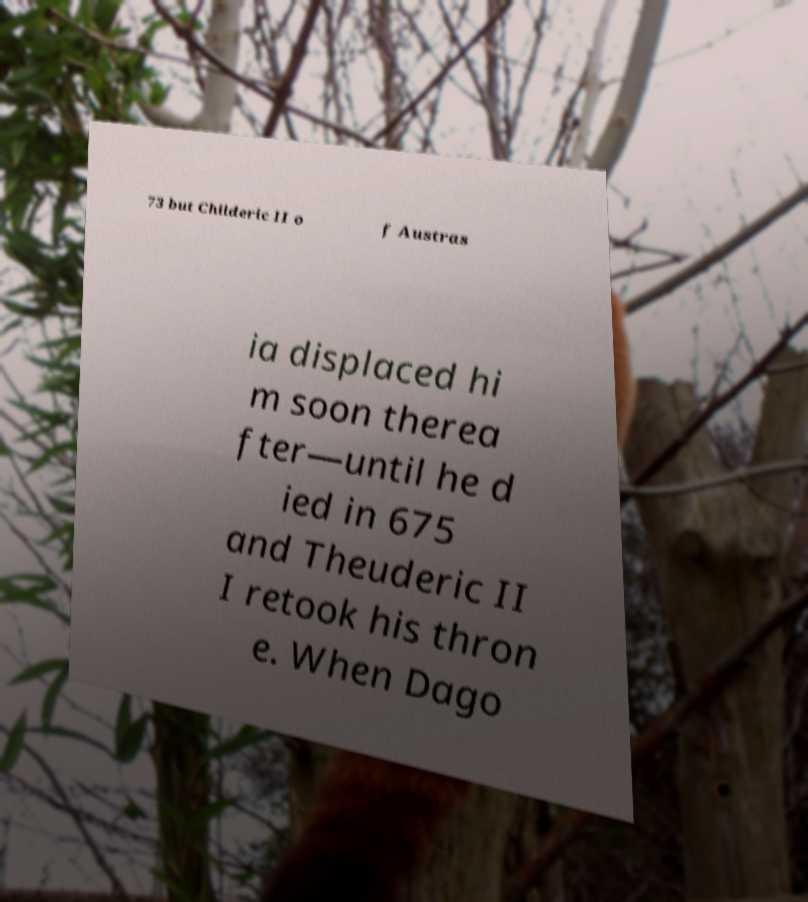Please identify and transcribe the text found in this image. 73 but Childeric II o f Austras ia displaced hi m soon therea fter—until he d ied in 675 and Theuderic II I retook his thron e. When Dago 